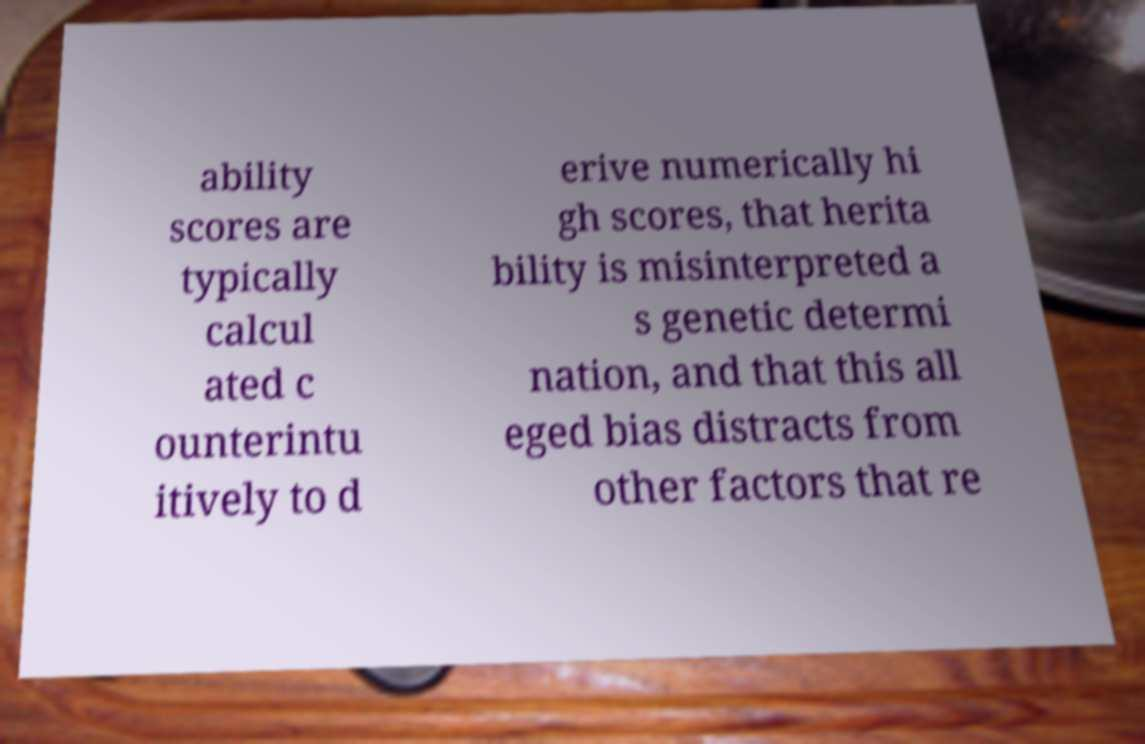Can you read and provide the text displayed in the image?This photo seems to have some interesting text. Can you extract and type it out for me? ability scores are typically calcul ated c ounterintu itively to d erive numerically hi gh scores, that herita bility is misinterpreted a s genetic determi nation, and that this all eged bias distracts from other factors that re 